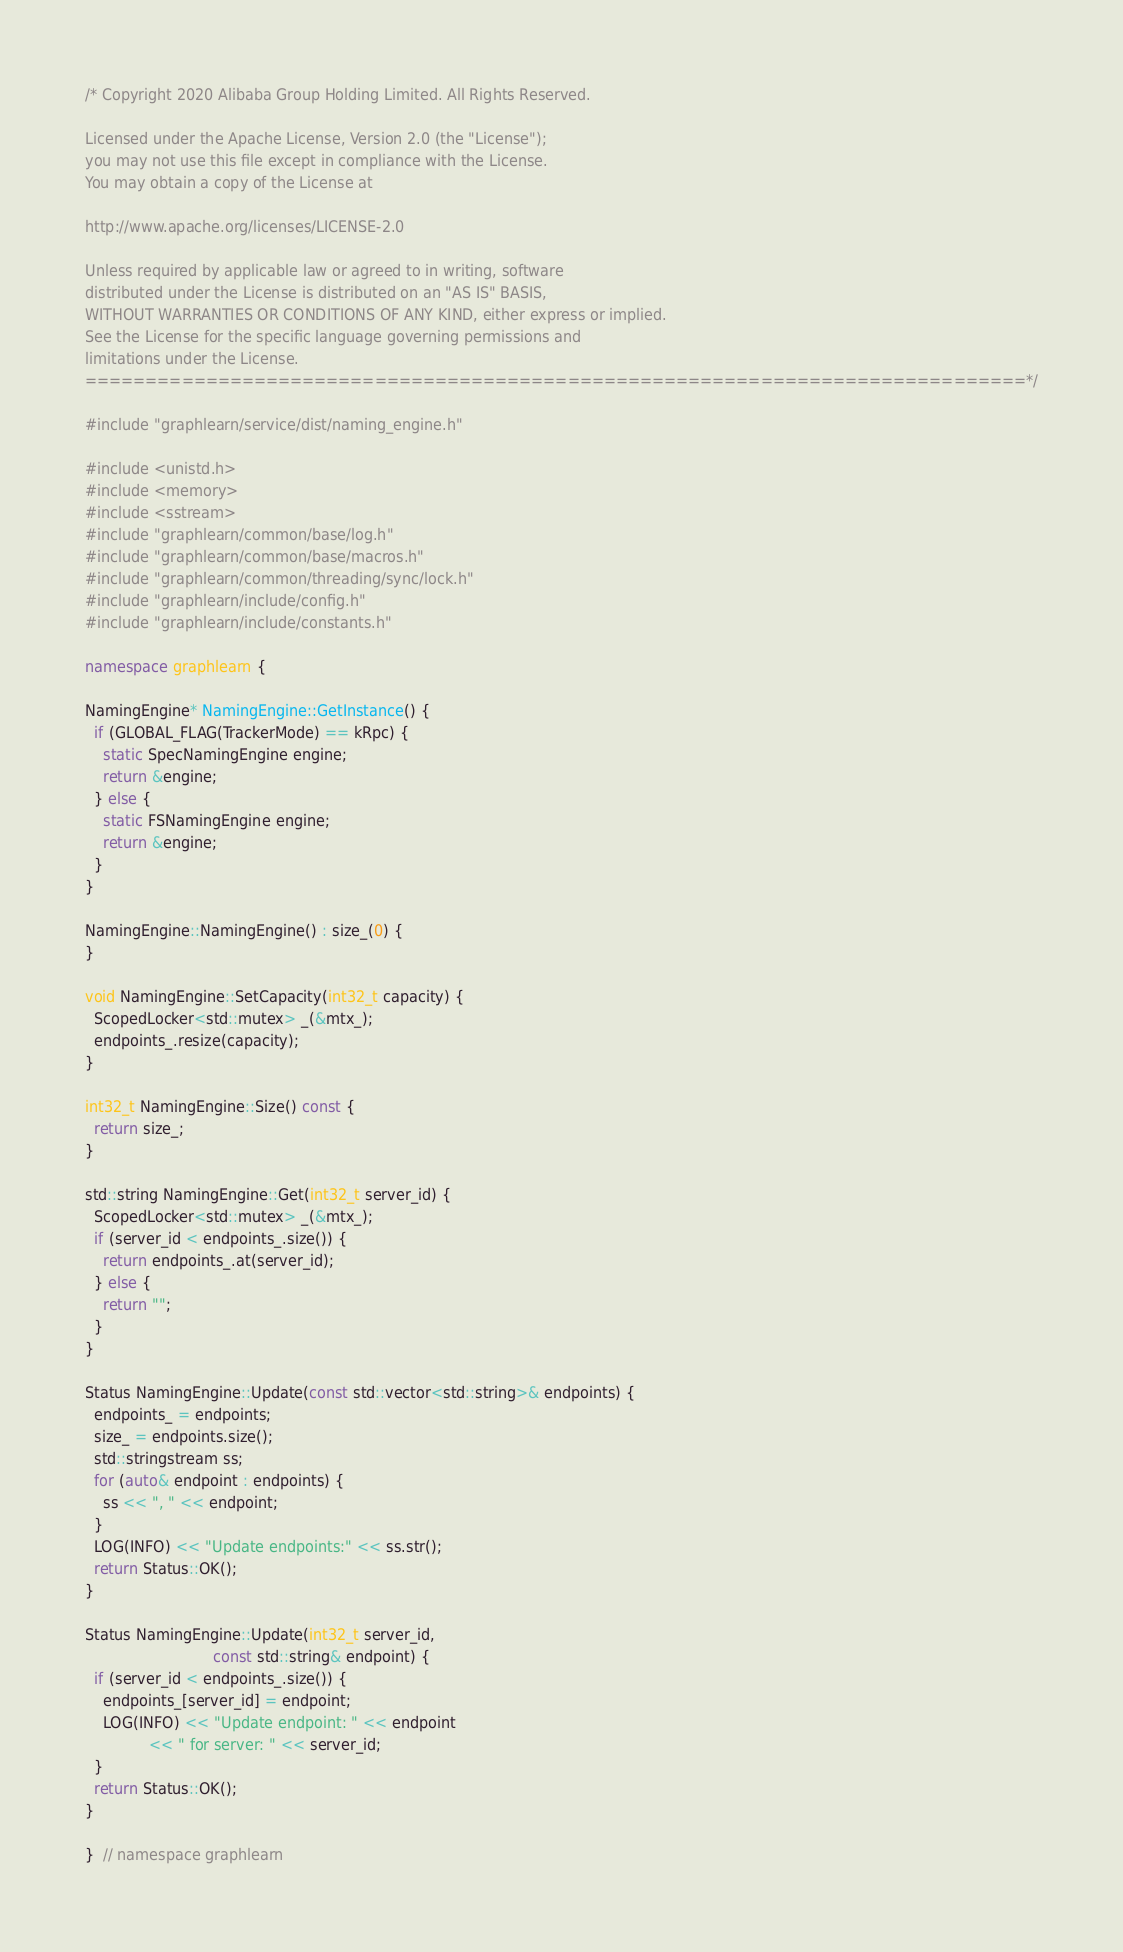<code> <loc_0><loc_0><loc_500><loc_500><_C++_>/* Copyright 2020 Alibaba Group Holding Limited. All Rights Reserved.

Licensed under the Apache License, Version 2.0 (the "License");
you may not use this file except in compliance with the License.
You may obtain a copy of the License at

http://www.apache.org/licenses/LICENSE-2.0

Unless required by applicable law or agreed to in writing, software
distributed under the License is distributed on an "AS IS" BASIS,
WITHOUT WARRANTIES OR CONDITIONS OF ANY KIND, either express or implied.
See the License for the specific language governing permissions and
limitations under the License.
==============================================================================*/

#include "graphlearn/service/dist/naming_engine.h"

#include <unistd.h>
#include <memory>
#include <sstream>
#include "graphlearn/common/base/log.h"
#include "graphlearn/common/base/macros.h"
#include "graphlearn/common/threading/sync/lock.h"
#include "graphlearn/include/config.h"
#include "graphlearn/include/constants.h"

namespace graphlearn {

NamingEngine* NamingEngine::GetInstance() {
  if (GLOBAL_FLAG(TrackerMode) == kRpc) {
    static SpecNamingEngine engine;
    return &engine;
  } else {
    static FSNamingEngine engine;
    return &engine;
  }
}

NamingEngine::NamingEngine() : size_(0) {
}

void NamingEngine::SetCapacity(int32_t capacity) {
  ScopedLocker<std::mutex> _(&mtx_);
  endpoints_.resize(capacity);
}

int32_t NamingEngine::Size() const {
  return size_;
}

std::string NamingEngine::Get(int32_t server_id) {
  ScopedLocker<std::mutex> _(&mtx_);
  if (server_id < endpoints_.size()) {
    return endpoints_.at(server_id);
  } else {
    return "";
  }
}

Status NamingEngine::Update(const std::vector<std::string>& endpoints) {
  endpoints_ = endpoints;
  size_ = endpoints.size();
  std::stringstream ss;
  for (auto& endpoint : endpoints) {
    ss << ", " << endpoint;
  }
  LOG(INFO) << "Update endpoints:" << ss.str();
  return Status::OK();
}

Status NamingEngine::Update(int32_t server_id,
                            const std::string& endpoint) {
  if (server_id < endpoints_.size()) {
    endpoints_[server_id] = endpoint;
    LOG(INFO) << "Update endpoint: " << endpoint
              << " for server: " << server_id;
  }
  return Status::OK();
}

}  // namespace graphlearn
</code> 